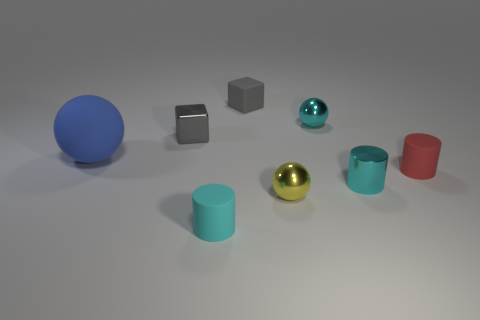How many tiny balls are made of the same material as the red cylinder?
Ensure brevity in your answer.  0. Does the gray thing that is to the right of the gray shiny thing have the same shape as the large object?
Provide a short and direct response. No. There is a small object that is in front of the yellow ball; what is its shape?
Offer a very short reply. Cylinder. There is a shiny sphere that is the same color as the shiny cylinder; what size is it?
Your response must be concise. Small. What is the material of the yellow ball?
Give a very brief answer. Metal. There is another ball that is the same size as the cyan ball; what color is it?
Offer a terse response. Yellow. There is a tiny rubber thing that is the same color as the metal cylinder; what is its shape?
Offer a very short reply. Cylinder. Does the small gray matte thing have the same shape as the red thing?
Keep it short and to the point. No. There is a tiny thing that is both in front of the small cyan metal cylinder and on the left side of the yellow object; what is its material?
Your response must be concise. Rubber. The cyan metallic cylinder is what size?
Keep it short and to the point. Small. 